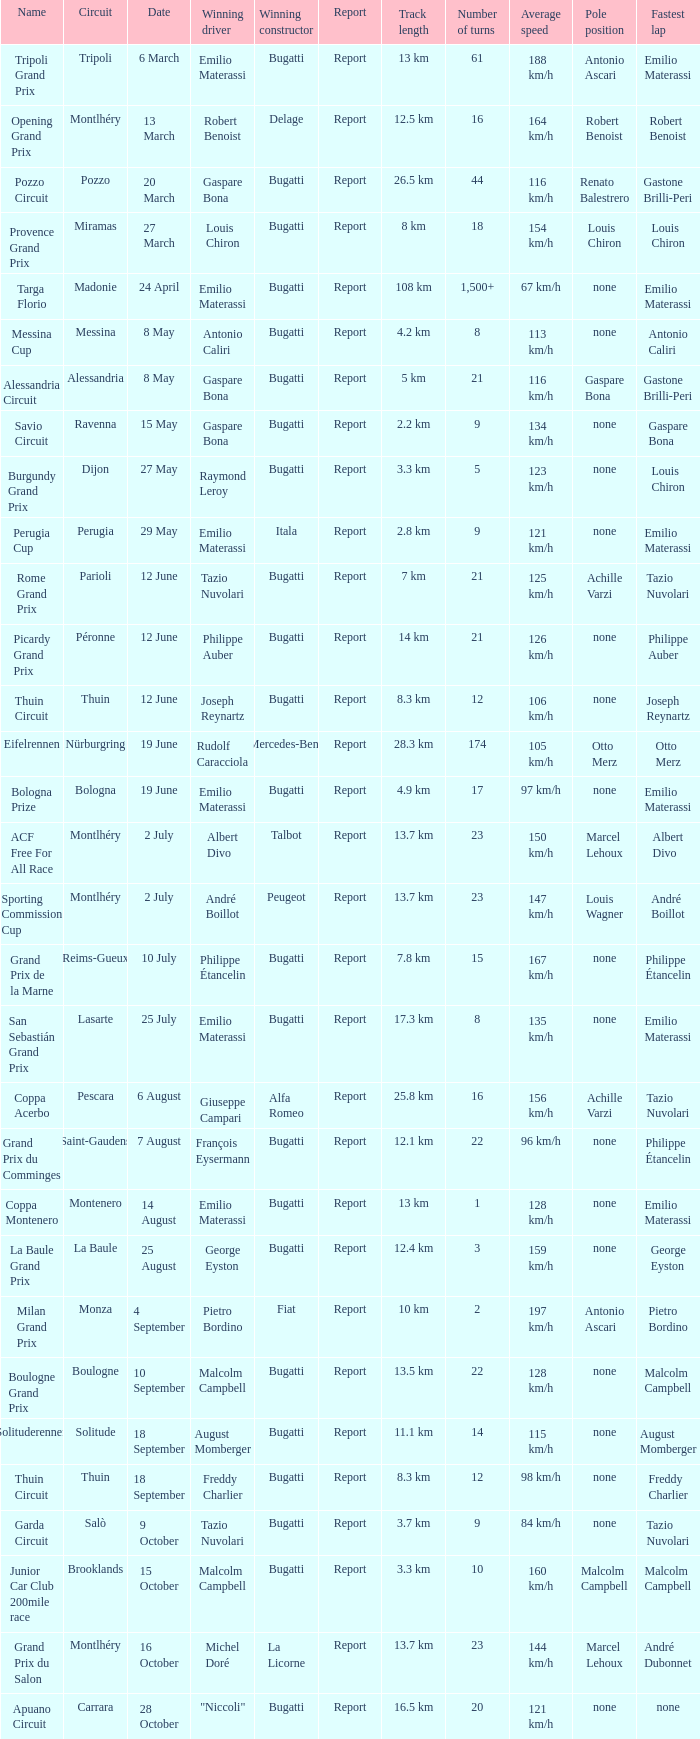Who was the winning constructor of the Grand Prix Du Salon ? La Licorne. Could you parse the entire table as a dict? {'header': ['Name', 'Circuit', 'Date', 'Winning driver', 'Winning constructor', 'Report', 'Track length', 'Number of turns', 'Average speed', 'Pole position', 'Fastest lap'], 'rows': [['Tripoli Grand Prix', 'Tripoli', '6 March', 'Emilio Materassi', 'Bugatti', 'Report', '13 km', '61', '188 km/h', 'Antonio Ascari', 'Emilio Materassi'], ['Opening Grand Prix', 'Montlhéry', '13 March', 'Robert Benoist', 'Delage', 'Report', '12.5 km', '16', '164 km/h', 'Robert Benoist', 'Robert Benoist'], ['Pozzo Circuit', 'Pozzo', '20 March', 'Gaspare Bona', 'Bugatti', 'Report', '26.5 km', '44', '116 km/h', 'Renato Balestrero', 'Gastone Brilli-Peri'], ['Provence Grand Prix', 'Miramas', '27 March', 'Louis Chiron', 'Bugatti', 'Report', '8 km', '18', '154 km/h', 'Louis Chiron', 'Louis Chiron'], ['Targa Florio', 'Madonie', '24 April', 'Emilio Materassi', 'Bugatti', 'Report', '108 km', '1,500+', '67 km/h', 'none', 'Emilio Materassi'], ['Messina Cup', 'Messina', '8 May', 'Antonio Caliri', 'Bugatti', 'Report', '4.2 km', '8', '113 km/h', 'none', 'Antonio Caliri'], ['Alessandria Circuit', 'Alessandria', '8 May', 'Gaspare Bona', 'Bugatti', 'Report', '5 km', '21', '116 km/h', 'Gaspare Bona', 'Gastone Brilli-Peri'], ['Savio Circuit', 'Ravenna', '15 May', 'Gaspare Bona', 'Bugatti', 'Report', '2.2 km', '9', '134 km/h', 'none', 'Gaspare Bona'], ['Burgundy Grand Prix', 'Dijon', '27 May', 'Raymond Leroy', 'Bugatti', 'Report', '3.3 km', '5', '123 km/h', 'none', 'Louis Chiron'], ['Perugia Cup', 'Perugia', '29 May', 'Emilio Materassi', 'Itala', 'Report', '2.8 km', '9', '121 km/h', 'none', 'Emilio Materassi'], ['Rome Grand Prix', 'Parioli', '12 June', 'Tazio Nuvolari', 'Bugatti', 'Report', '7 km', '21', '125 km/h', 'Achille Varzi', 'Tazio Nuvolari'], ['Picardy Grand Prix', 'Péronne', '12 June', 'Philippe Auber', 'Bugatti', 'Report', '14 km', '21', '126 km/h', 'none', 'Philippe Auber'], ['Thuin Circuit', 'Thuin', '12 June', 'Joseph Reynartz', 'Bugatti', 'Report', '8.3 km', '12', '106 km/h', 'none', 'Joseph Reynartz'], ['Eifelrennen', 'Nürburgring', '19 June', 'Rudolf Caracciola', 'Mercedes-Benz', 'Report', '28.3 km', '174', '105 km/h', 'Otto Merz', 'Otto Merz'], ['Bologna Prize', 'Bologna', '19 June', 'Emilio Materassi', 'Bugatti', 'Report', '4.9 km', '17', '97 km/h', 'none', 'Emilio Materassi'], ['ACF Free For All Race', 'Montlhéry', '2 July', 'Albert Divo', 'Talbot', 'Report', '13.7 km', '23', '150 km/h', 'Marcel Lehoux', 'Albert Divo'], ['Sporting Commission Cup', 'Montlhéry', '2 July', 'André Boillot', 'Peugeot', 'Report', '13.7 km', '23', '147 km/h', 'Louis Wagner', 'André Boillot'], ['Grand Prix de la Marne', 'Reims-Gueux', '10 July', 'Philippe Étancelin', 'Bugatti', 'Report', '7.8 km', '15', '167 km/h', 'none', 'Philippe Étancelin'], ['San Sebastián Grand Prix', 'Lasarte', '25 July', 'Emilio Materassi', 'Bugatti', 'Report', '17.3 km', '8', '135 km/h', 'none', 'Emilio Materassi'], ['Coppa Acerbo', 'Pescara', '6 August', 'Giuseppe Campari', 'Alfa Romeo', 'Report', '25.8 km', '16', '156 km/h', 'Achille Varzi', 'Tazio Nuvolari'], ['Grand Prix du Comminges', 'Saint-Gaudens', '7 August', 'François Eysermann', 'Bugatti', 'Report', '12.1 km', '22', '96 km/h', 'none', 'Philippe Étancelin'], ['Coppa Montenero', 'Montenero', '14 August', 'Emilio Materassi', 'Bugatti', 'Report', '13 km', '1', '128 km/h', 'none', 'Emilio Materassi'], ['La Baule Grand Prix', 'La Baule', '25 August', 'George Eyston', 'Bugatti', 'Report', '12.4 km', '3', '159 km/h', 'none', 'George Eyston'], ['Milan Grand Prix', 'Monza', '4 September', 'Pietro Bordino', 'Fiat', 'Report', '10 km', '2', '197 km/h', 'Antonio Ascari', 'Pietro Bordino'], ['Boulogne Grand Prix', 'Boulogne', '10 September', 'Malcolm Campbell', 'Bugatti', 'Report', '13.5 km', '22', '128 km/h', 'none', 'Malcolm Campbell'], ['Solituderennen', 'Solitude', '18 September', 'August Momberger', 'Bugatti', 'Report', '11.1 km', '14', '115 km/h', 'none', 'August Momberger'], ['Thuin Circuit', 'Thuin', '18 September', 'Freddy Charlier', 'Bugatti', 'Report', '8.3 km', '12', '98 km/h', 'none', 'Freddy Charlier'], ['Garda Circuit', 'Salò', '9 October', 'Tazio Nuvolari', 'Bugatti', 'Report', '3.7 km', '9', '84 km/h', 'none', 'Tazio Nuvolari'], ['Junior Car Club 200mile race', 'Brooklands', '15 October', 'Malcolm Campbell', 'Bugatti', 'Report', '3.3 km', '10', '160 km/h', 'Malcolm Campbell', 'Malcolm Campbell'], ['Grand Prix du Salon', 'Montlhéry', '16 October', 'Michel Doré', 'La Licorne', 'Report', '13.7 km', '23', '144 km/h', 'Marcel Lehoux', 'André Dubonnet'], ['Apuano Circuit', 'Carrara', '28 October', '"Niccoli"', 'Bugatti', 'Report', '16.5 km', '20', '121 km/h', 'none', 'none']]} 